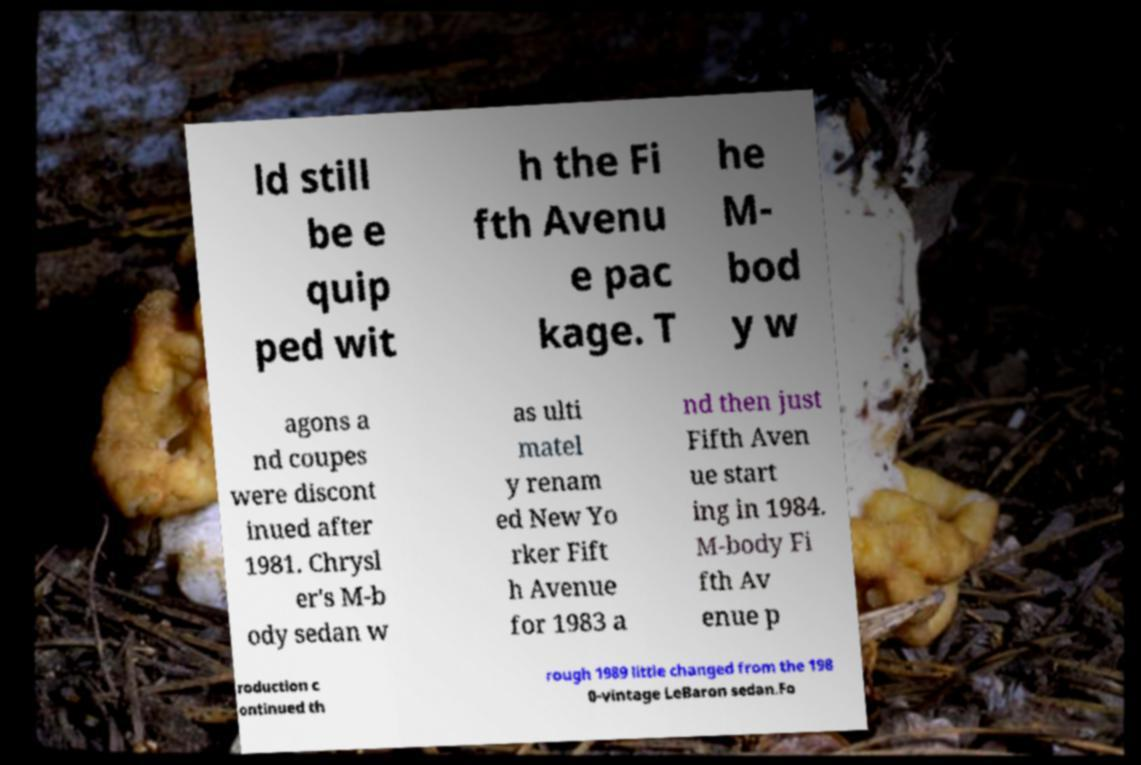Could you extract and type out the text from this image? ld still be e quip ped wit h the Fi fth Avenu e pac kage. T he M- bod y w agons a nd coupes were discont inued after 1981. Chrysl er's M-b ody sedan w as ulti matel y renam ed New Yo rker Fift h Avenue for 1983 a nd then just Fifth Aven ue start ing in 1984. M-body Fi fth Av enue p roduction c ontinued th rough 1989 little changed from the 198 0-vintage LeBaron sedan.Fo 